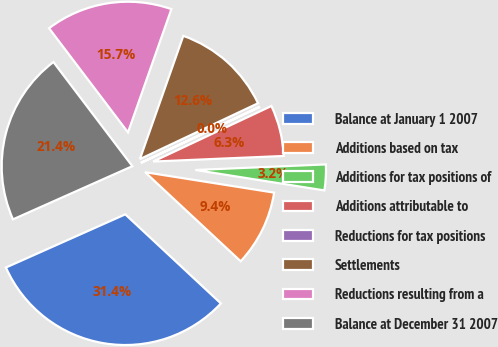<chart> <loc_0><loc_0><loc_500><loc_500><pie_chart><fcel>Balance at January 1 2007<fcel>Additions based on tax<fcel>Additions for tax positions of<fcel>Additions attributable to<fcel>Reductions for tax positions<fcel>Settlements<fcel>Reductions resulting from a<fcel>Balance at December 31 2007<nl><fcel>31.39%<fcel>9.44%<fcel>3.18%<fcel>6.31%<fcel>0.04%<fcel>12.58%<fcel>15.71%<fcel>21.35%<nl></chart> 